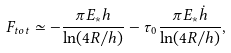<formula> <loc_0><loc_0><loc_500><loc_500>F _ { t o t } \simeq - \frac { \pi E _ { * } h } { \ln ( 4 R / h ) } - \tau _ { 0 } \frac { \pi E _ { * } \dot { h } } { \ln ( 4 R / h ) } ,</formula> 